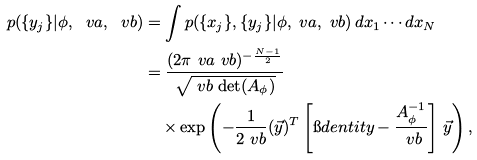<formula> <loc_0><loc_0><loc_500><loc_500>p ( \{ y _ { j } \} | \phi , \ v a , \ v b ) & = \int p ( \{ x _ { j } \} , \{ y _ { j } \} | \phi , \ v a , \ v b ) \, d x _ { 1 } \cdots d x _ { N } \\ & = \frac { ( 2 \pi \ v a \ v b ) ^ { - \frac { N - 1 } { 2 } } } { \sqrt { \ v b \, \det ( A _ { \phi } ) } } \\ & \quad \times \exp \left ( - \frac { 1 } { 2 \ v b } ( \vec { y } ) ^ { T } \left [ \i d e n t i t y - \frac { A _ { \phi } ^ { - 1 } } { \ v b } \right ] \, \vec { y } \right ) ,</formula> 